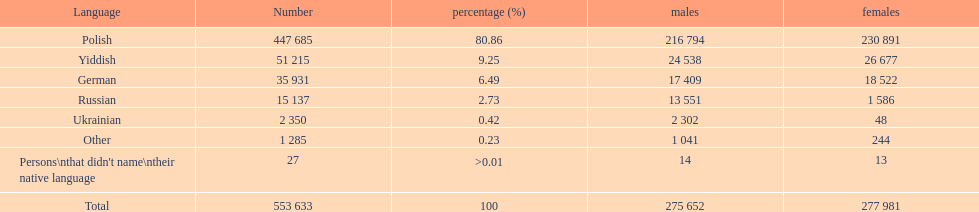How many people didn't name their native language? 27. 